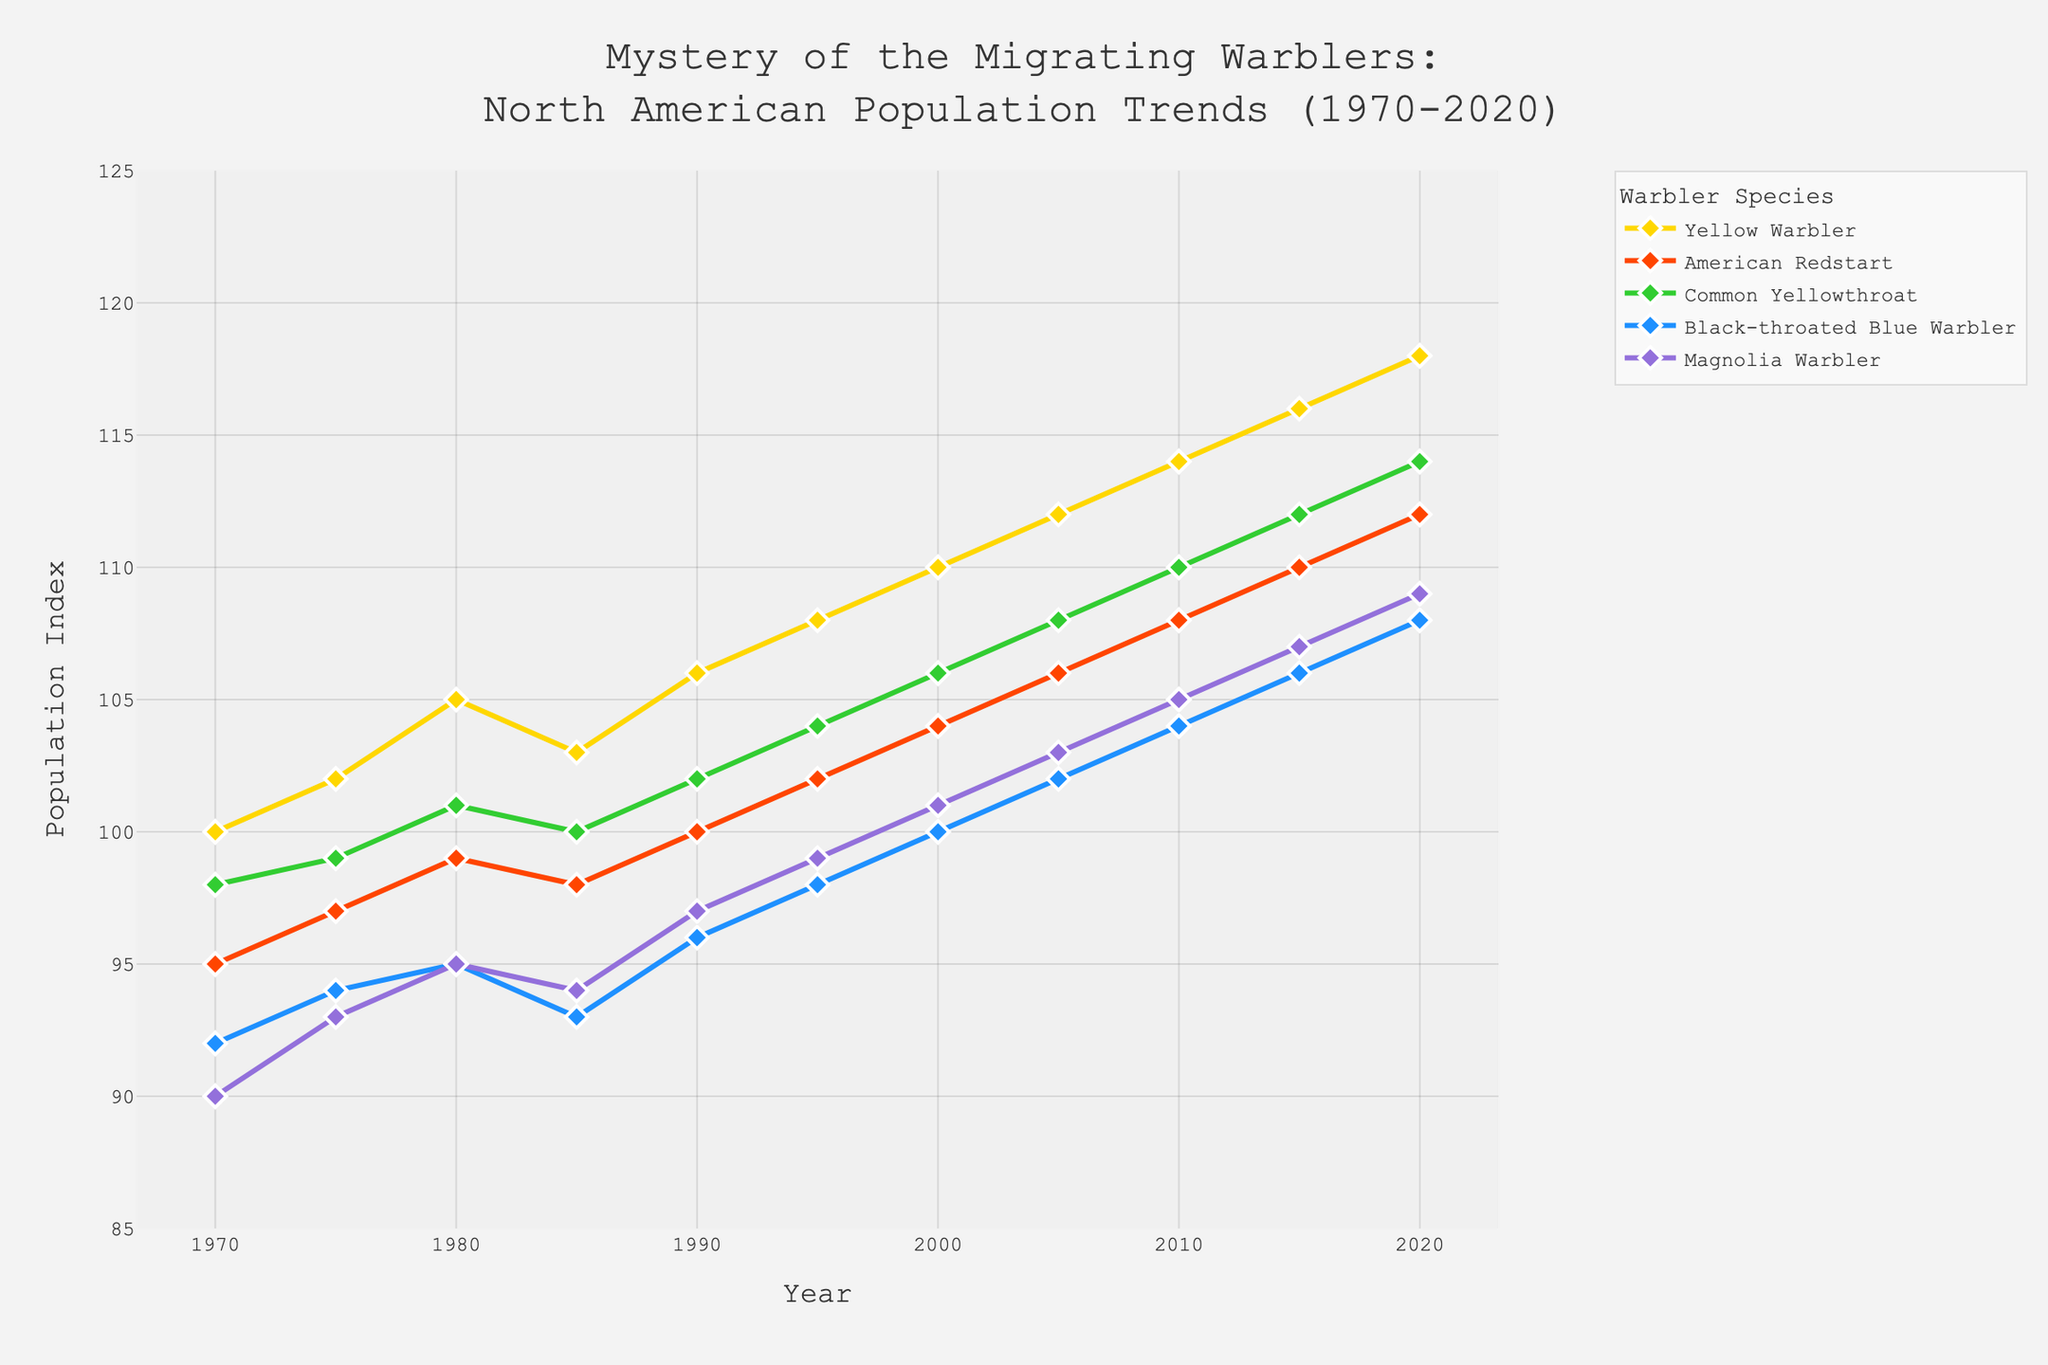What year did the population of the Yellow Warbler start showing a consistent increasing trend? The population index of the Yellow Warbler begins at 100 in 1970 and increases incrementally every subsequent recorded year, reaching 118 by 2020. This indicates a consistent increasing trend throughout the entire period.
Answer: 1970 What is the difference between the highest and lowest population index for the American Redstart over the years? The lowest population index for the American Redstart is 95 (1970) and the highest is 112 (2020). Therefore, the difference is 112 - 95 = 17.
Answer: 17 Which species had the most significant population increase from 1970 to 2020? Comparing the starting and ending population indices for each species, the Yellow Warbler increased from 100 to 118, the American Redstart from 95 to 112, the Common Yellowthroat from 98 to 114, the Black-throated Blue Warbler from 92 to 108, and the Magnolia Warbler from 90 to 109. The Common Yellowthroat has the highest increase of 16 points (114 - 98).
Answer: Common Yellowthroat What is the average population index for the Magnolia Warbler across all recorded years? Sum all population indices for the Magnolia Warbler and divide by the total number of years: (90 + 93 + 95 + 94 + 97 + 99 + 101 + 103 + 105 + 107 + 109) / 11 = 1093 / 11 ≈ 99.36.
Answer: 99.36 How does the population of the Black-throated Blue Warbler in 2000 compare to the Common Yellowthroat in the same year? In 2000, the Black-throated Blue Warbler population index is 100 and the Common Yellowthroat is 106. Therefore, the Common Yellowthroat has a higher population index.
Answer: Common Yellowthroat is higher Between the years 1985 and 1990, which species experienced the greatest change in population index, and what was the value? Calculate the absolute change for each species between 1985 and 1990: Yellow Warbler (106 - 103 = 3), American Redstart (100 - 98 = 2), Common Yellowthroat (102 - 100 = 2), Black-throated Blue Warbler (96 - 93 = 3), Magnolia Warbler (97 - 94 = 3). Therefore, Yellow Warbler, Black-throated Blue Warbler, and Magnolia Warbler all experienced the greatest change of 3.
Answer: Yellow Warbler, Black-throated Blue Warbler, Magnolia Warbler (all 3) What color line corresponds to the American Redstart in the figure? Observing the color coding from the description in the provided code, the American Redstart's line color is described as close to orange-red.
Answer: Orange-Red During which decade did the Common Yellowthroat achieve its highest population index, and what was the value? The highest population index for the Common Yellowthroat is 114 in 2020. Examining the data decade-wise, this highest point is achieved between 2010 and 2020.
Answer: 2010-2020, 114 Which species had the lowest population index in 1970, and what was that value? Refer to the 1970 data: Yellow Warbler (100), American Redstart (95), Common Yellowthroat (98), Black-throated Blue Warbler (92), Magnolia Warbler (90). Thus, the Magnolia Warbler had the lowest index at 90.
Answer: Magnolia Warbler, 90 What is the overall trend for all species combined, and how would you describe it? Observing the values from 1970 to 2020 for all species, all warblers show a steady upward trend in their population indices. This indicates an overall positive growth in population for these species over the 50 years.
Answer: Steady upward trend During which years does the population index of the Yellow Warbler surpass 110, and by how much does it exceed 110 at that time? The population index of the Yellow Warbler surpasses 110 in 2010 (114), 2015 (116), and 2020 (118). The amount by which it exceeds 110 in these years are 4, 6, and 8 respectively.
Answer: 2010 (4), 2015 (6), 2020 (8) 